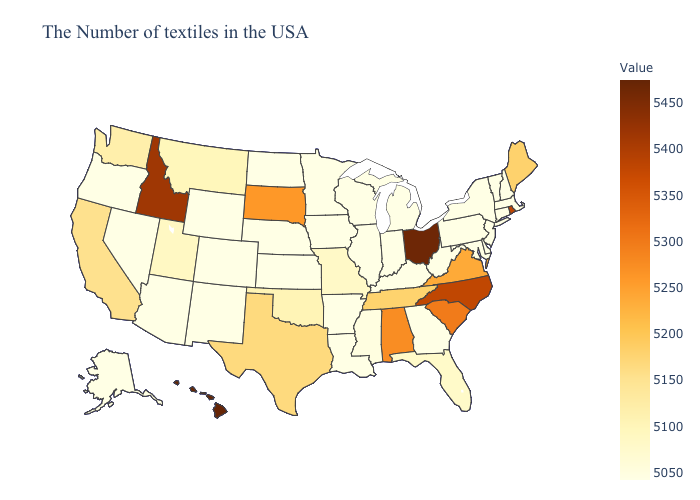Does Hawaii have the highest value in the USA?
Give a very brief answer. Yes. Among the states that border Oklahoma , does Texas have the lowest value?
Be succinct. No. Does New Mexico have the lowest value in the West?
Answer briefly. Yes. Which states have the lowest value in the USA?
Keep it brief. Massachusetts, New Hampshire, Vermont, Connecticut, New York, New Jersey, Delaware, Maryland, Pennsylvania, West Virginia, Georgia, Michigan, Kentucky, Indiana, Wisconsin, Illinois, Louisiana, Arkansas, Minnesota, Iowa, Kansas, Nebraska, North Dakota, Wyoming, Colorado, New Mexico, Arizona, Nevada, Oregon, Alaska. Among the states that border Ohio , which have the lowest value?
Quick response, please. Pennsylvania, West Virginia, Michigan, Kentucky, Indiana. 